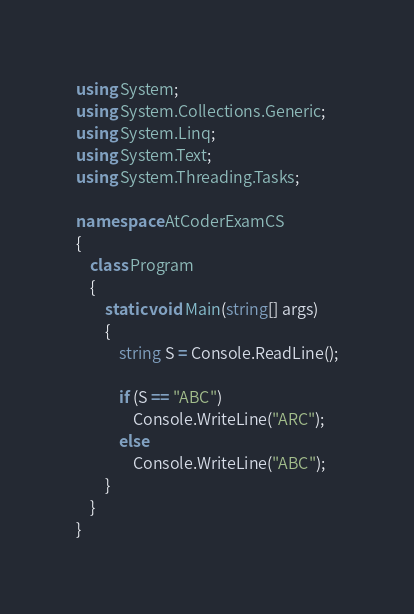<code> <loc_0><loc_0><loc_500><loc_500><_C#_>using System;
using System.Collections.Generic;
using System.Linq;
using System.Text;
using System.Threading.Tasks;

namespace AtCoderExamCS
{
    class Program
    {
        static void Main(string[] args)
        {
            string S = Console.ReadLine();

            if (S == "ABC")
                Console.WriteLine("ARC");
            else
                Console.WriteLine("ABC");
        }
    }
}
</code> 